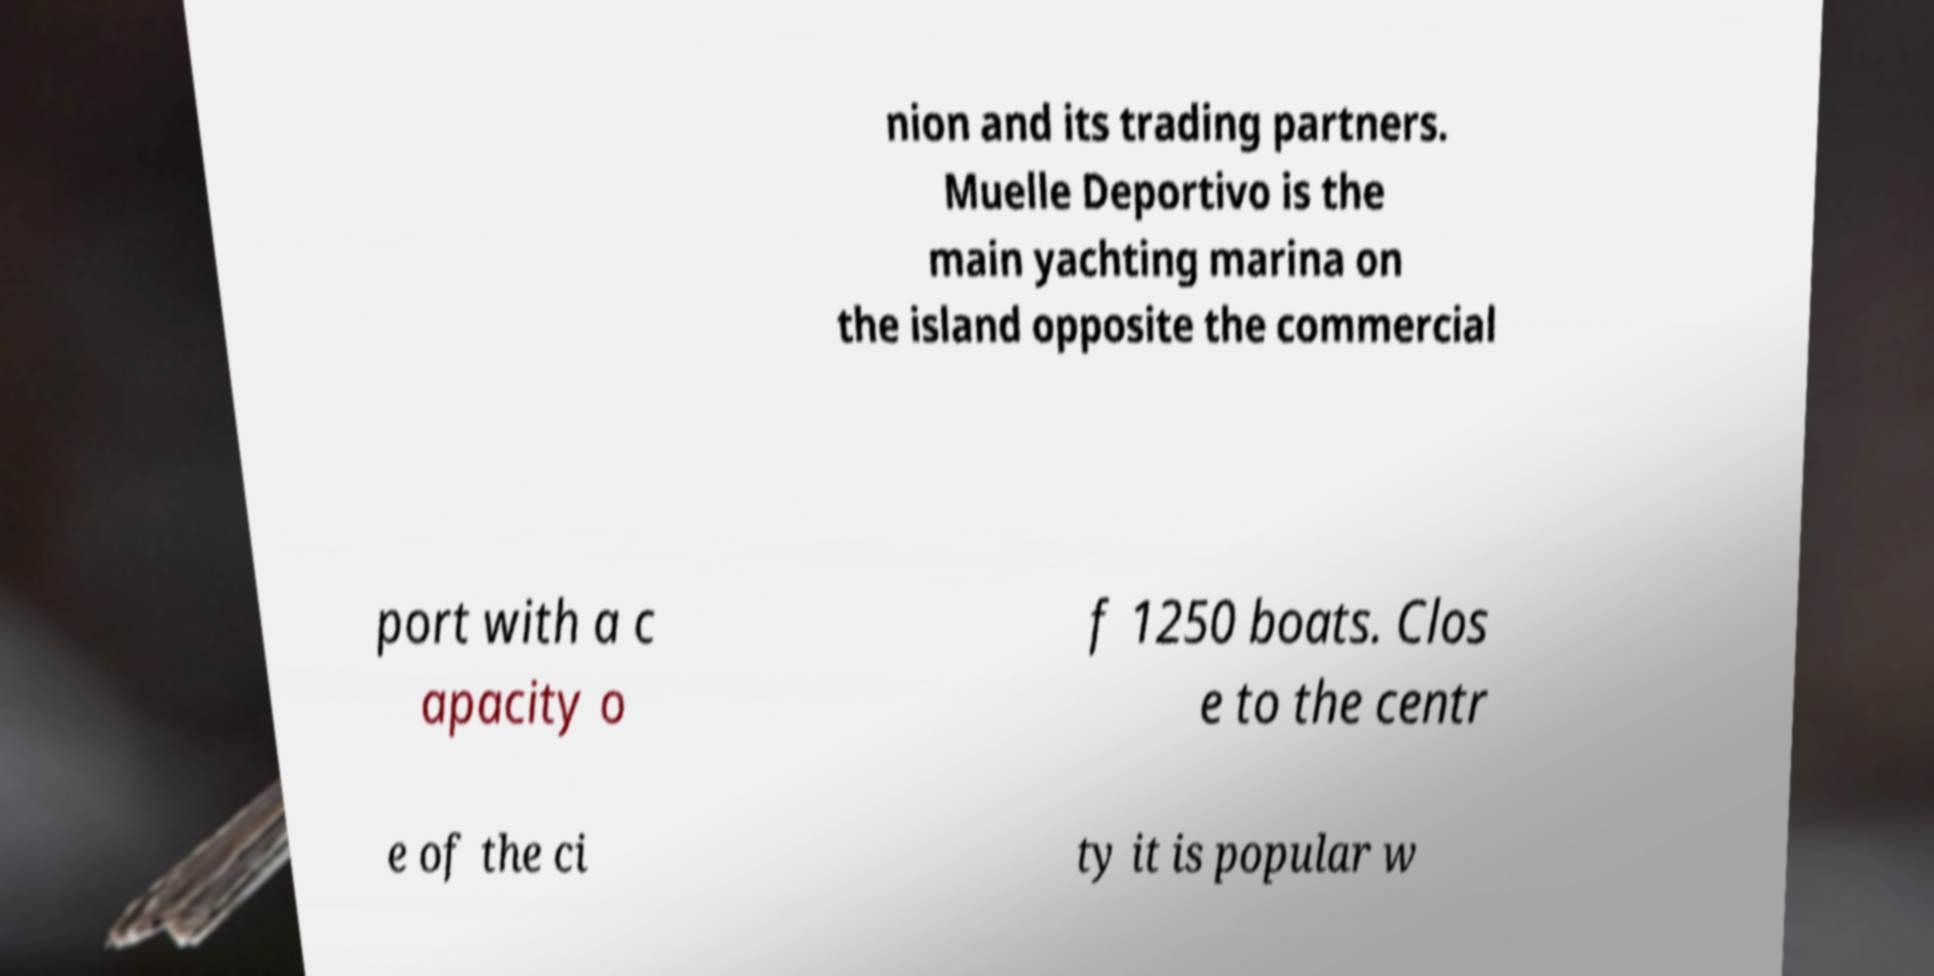Can you read and provide the text displayed in the image?This photo seems to have some interesting text. Can you extract and type it out for me? nion and its trading partners. Muelle Deportivo is the main yachting marina on the island opposite the commercial port with a c apacity o f 1250 boats. Clos e to the centr e of the ci ty it is popular w 